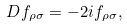<formula> <loc_0><loc_0><loc_500><loc_500>D f _ { \rho \sigma } = - 2 i f _ { \rho \sigma } ,</formula> 